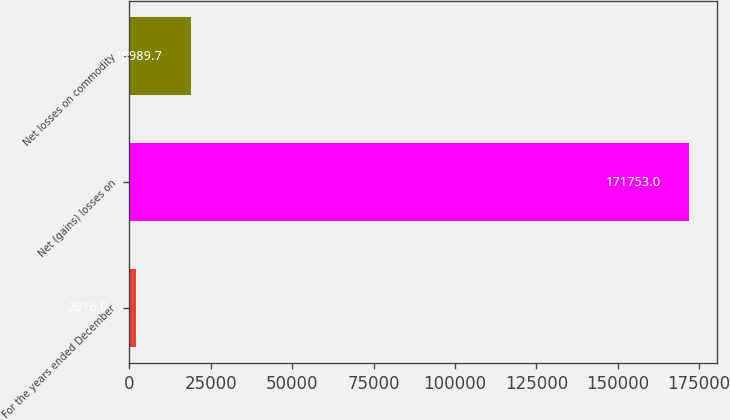Convert chart. <chart><loc_0><loc_0><loc_500><loc_500><bar_chart><fcel>For the years ended December<fcel>Net (gains) losses on<fcel>Net losses on commodity<nl><fcel>2016<fcel>171753<fcel>18989.7<nl></chart> 